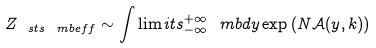<formula> <loc_0><loc_0><loc_500><loc_500>Z _ { \ s t s \ m b { e f f } } \sim \int \lim i t s _ { - \infty } ^ { + \infty } \ m b { d } y \exp \left ( N \mathcal { A } ( y , k ) \right )</formula> 